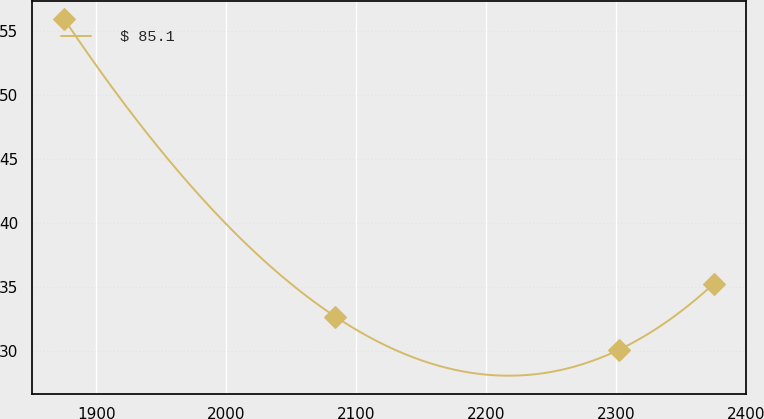Convert chart to OTSL. <chart><loc_0><loc_0><loc_500><loc_500><line_chart><ecel><fcel>$ 85.1<nl><fcel>1875.26<fcel>55.93<nl><fcel>2084.09<fcel>32.66<nl><fcel>2302.33<fcel>30.07<nl><fcel>2375.48<fcel>35.25<nl></chart> 